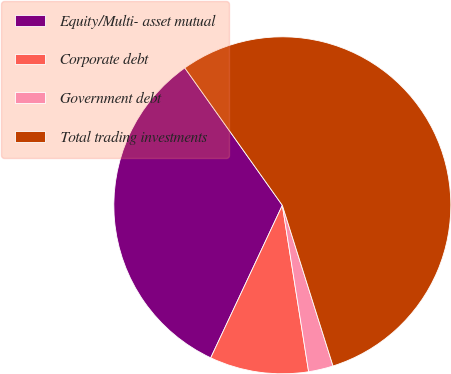Convert chart to OTSL. <chart><loc_0><loc_0><loc_500><loc_500><pie_chart><fcel>Equity/Multi- asset mutual<fcel>Corporate debt<fcel>Government debt<fcel>Total trading investments<nl><fcel>33.19%<fcel>9.48%<fcel>2.37%<fcel>54.96%<nl></chart> 